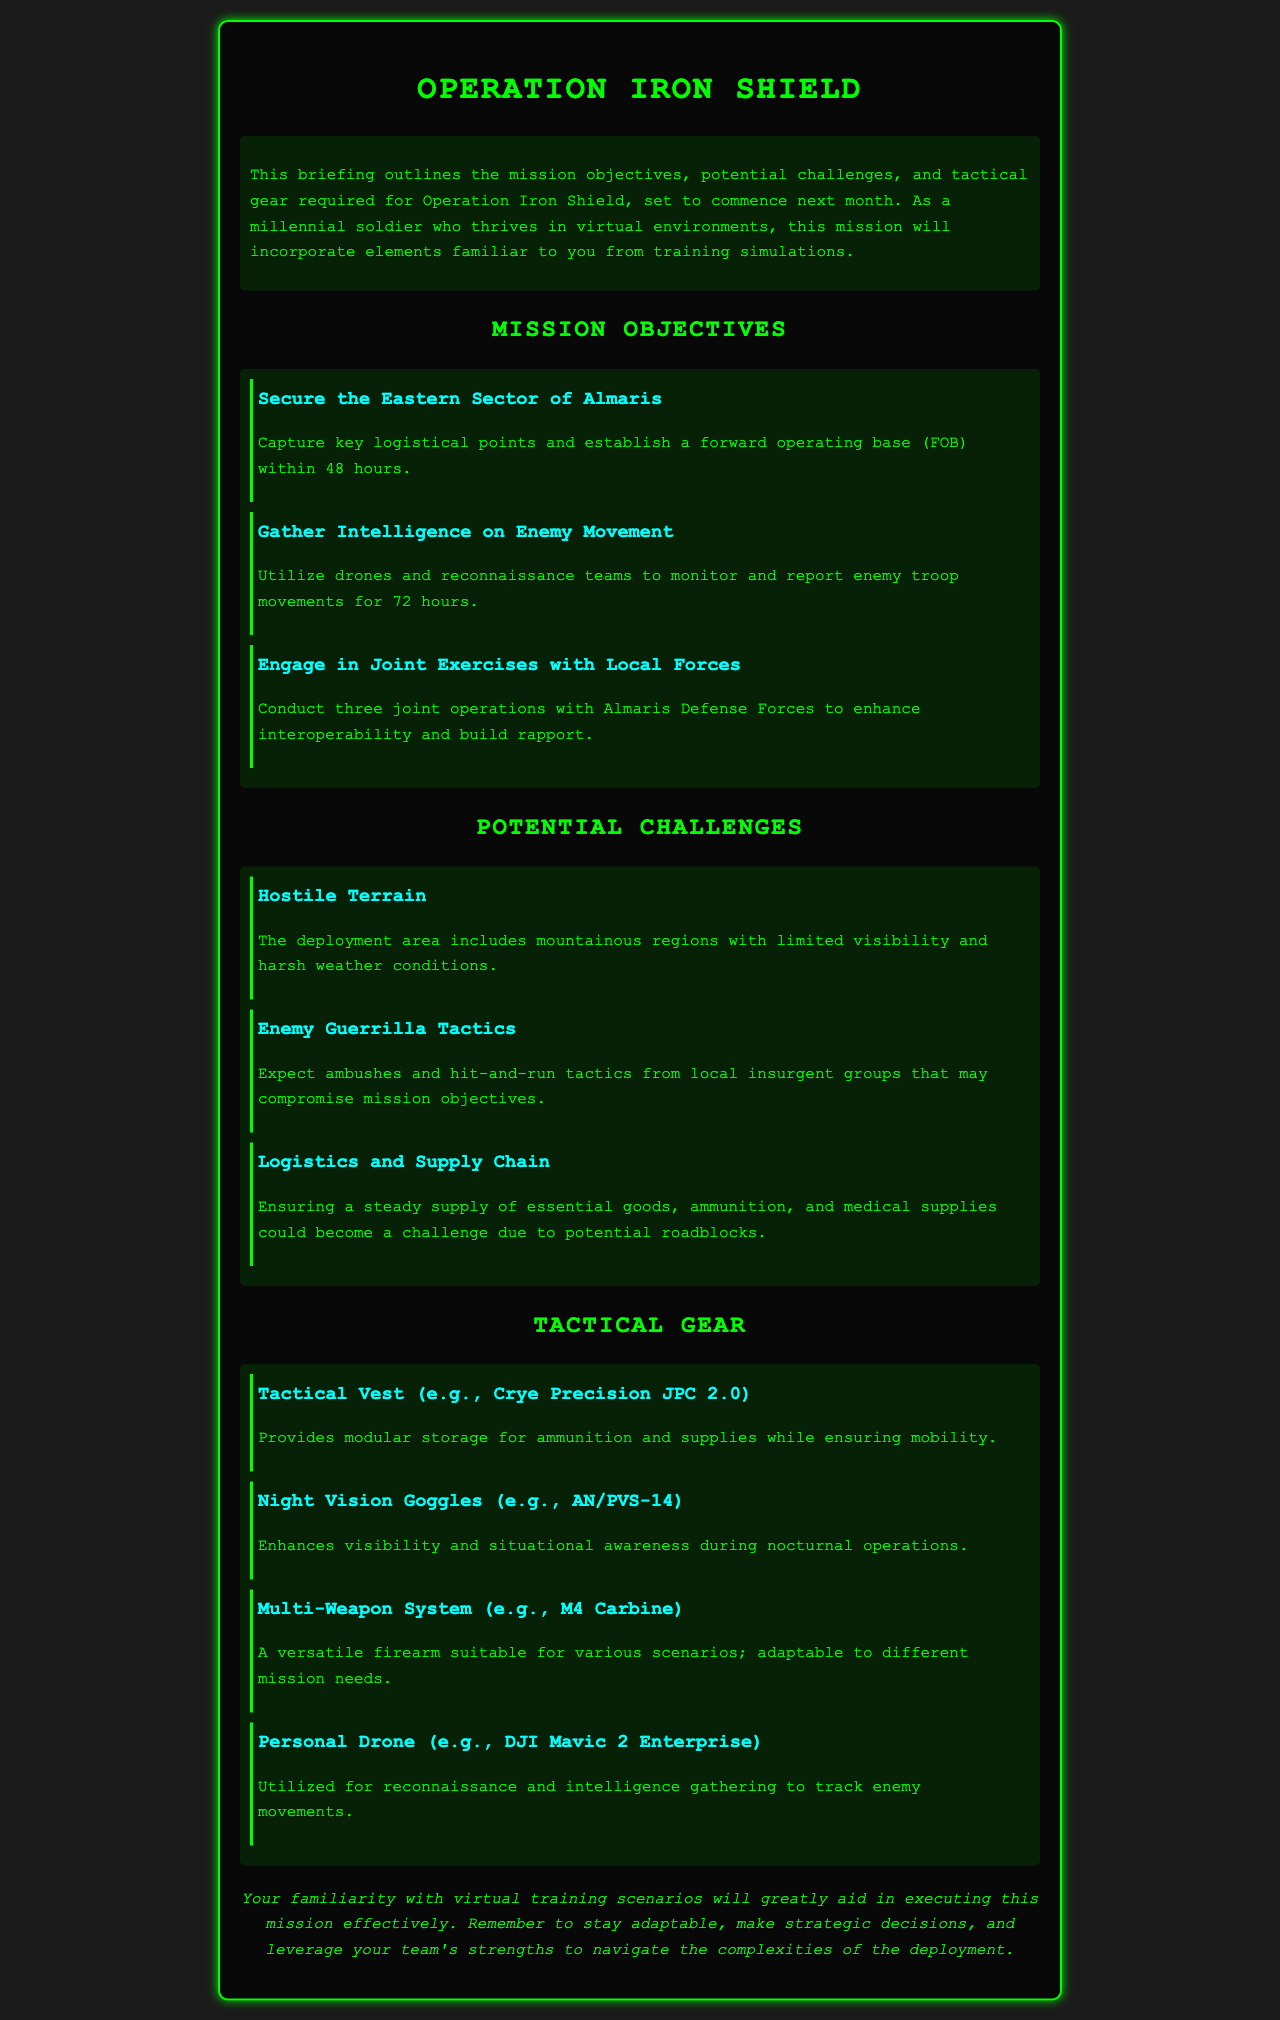What is the name of the operation? The document is about the deployment briefing for a specific military operation, which is Operation Iron Shield.
Answer: Operation Iron Shield How long is the intelligence gathering objective set for? The objective includes monitoring and reporting enemy troop movements for a duration specified in the document.
Answer: 72 hours What is the first mission objective? The first objective listed is to secure a specific area, which involves capturing key points.
Answer: Secure the Eastern Sector of Almaris What type of tactical gear is mentioned for reconnaissance? A specific type of gear used for intelligence gathering during the operation is referenced in the document.
Answer: Personal Drone (e.g., DJI Mavic 2 Enterprise) What challenge involves weather conditions? Among the listed challenges, one specifically addresses the difficulties posed by a certain aspect of the terrain and climate.
Answer: Hostile Terrain How many joint operations are to be conducted with local forces? The document specifies a number regarding joint exercises aimed at fostering collaboration with local groups.
Answer: Three What does the tactical vest provide? The document mentions a specific benefit of the tactical vest related to storage and mobility.
Answer: Modular storage for ammunition and supplies Which night vision goggles are mentioned? A specific model of night vision goggles is identified in the tactical gear section of the document.
Answer: AN/PVS-14 What is the primary difficulty in logistics? One of the main challenges noted in the mission briefing is associated with the handling of supplies during the operation.
Answer: Potential roadblocks 